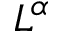<formula> <loc_0><loc_0><loc_500><loc_500>L ^ { \alpha }</formula> 